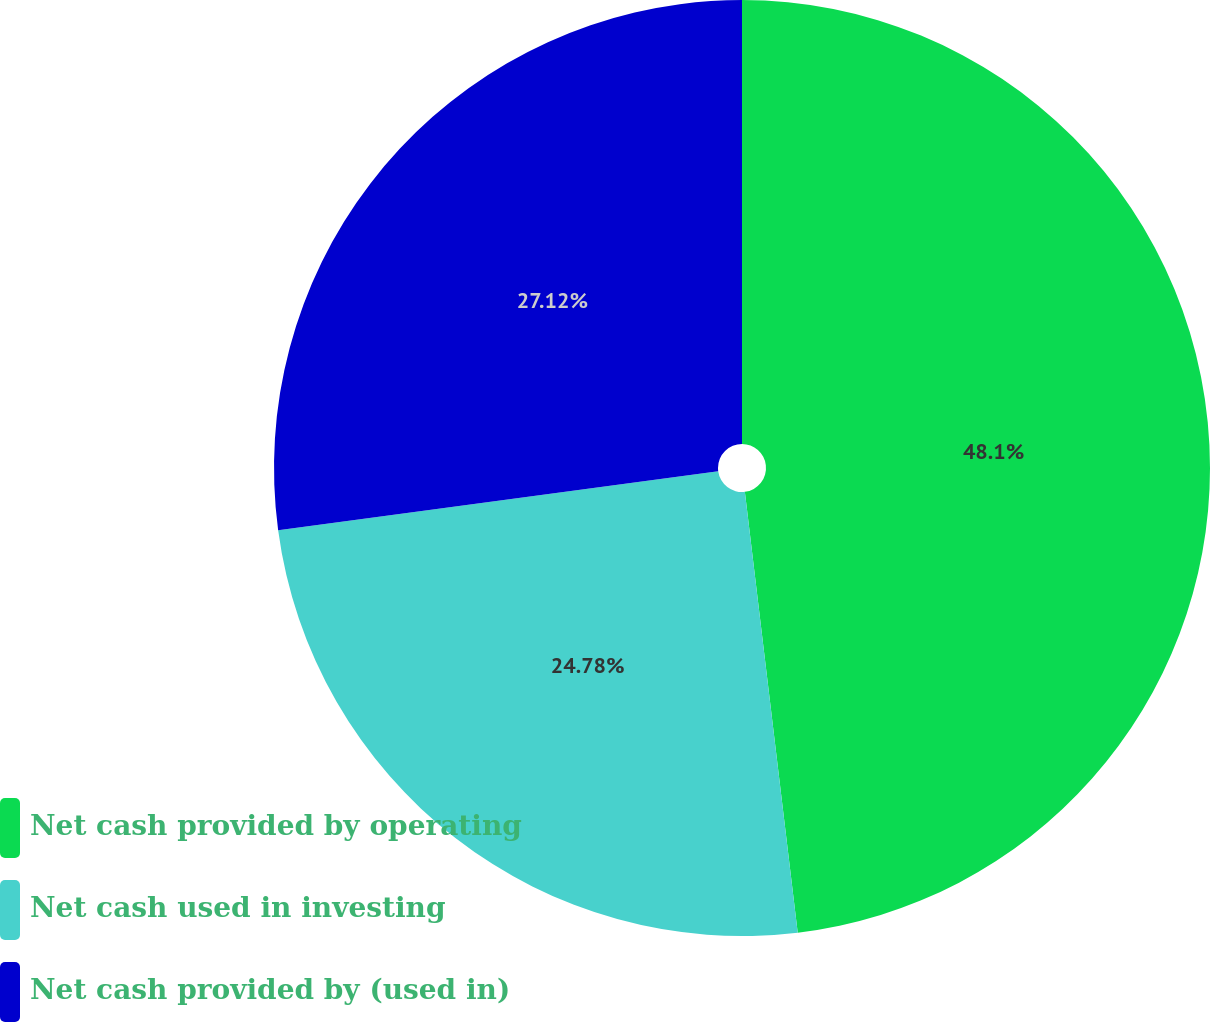Convert chart to OTSL. <chart><loc_0><loc_0><loc_500><loc_500><pie_chart><fcel>Net cash provided by operating<fcel>Net cash used in investing<fcel>Net cash provided by (used in)<nl><fcel>48.1%<fcel>24.78%<fcel>27.12%<nl></chart> 